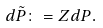Convert formula to latex. <formula><loc_0><loc_0><loc_500><loc_500>d \tilde { P } & \colon = Z d P .</formula> 